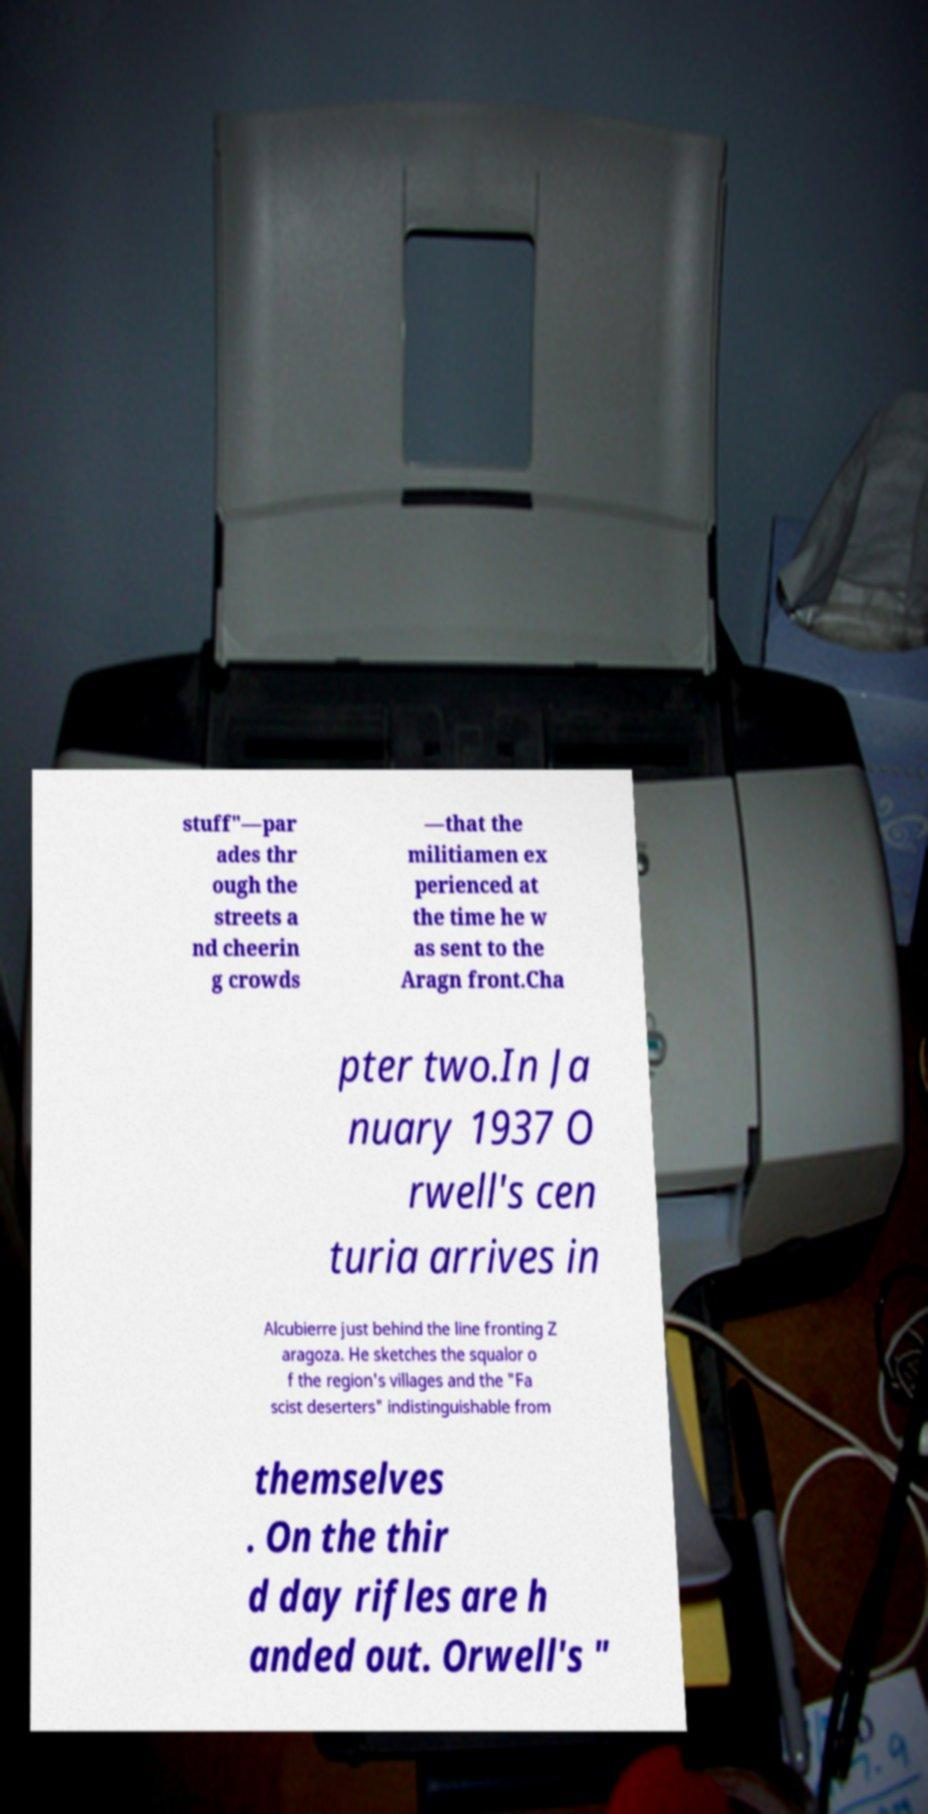Could you extract and type out the text from this image? stuff"—par ades thr ough the streets a nd cheerin g crowds —that the militiamen ex perienced at the time he w as sent to the Aragn front.Cha pter two.In Ja nuary 1937 O rwell's cen turia arrives in Alcubierre just behind the line fronting Z aragoza. He sketches the squalor o f the region's villages and the "Fa scist deserters" indistinguishable from themselves . On the thir d day rifles are h anded out. Orwell's " 